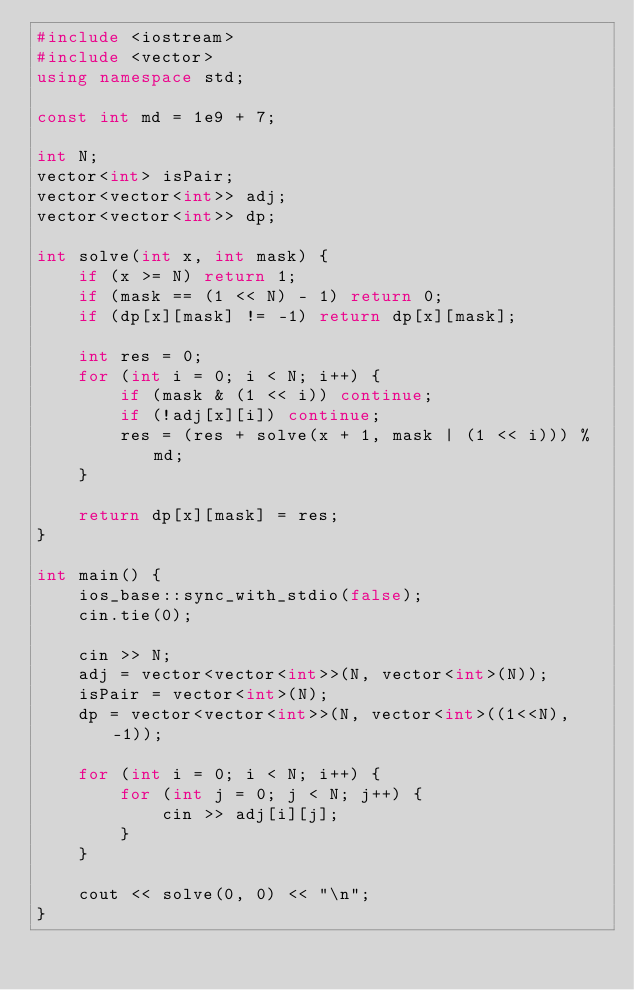<code> <loc_0><loc_0><loc_500><loc_500><_C++_>#include <iostream>
#include <vector>
using namespace std;

const int md = 1e9 + 7;

int N;
vector<int> isPair;
vector<vector<int>> adj;
vector<vector<int>> dp;

int solve(int x, int mask) {
    if (x >= N) return 1;
    if (mask == (1 << N) - 1) return 0;
    if (dp[x][mask] != -1) return dp[x][mask];

    int res = 0;
    for (int i = 0; i < N; i++) {
        if (mask & (1 << i)) continue;
        if (!adj[x][i]) continue;
        res = (res + solve(x + 1, mask | (1 << i))) % md;
    }

    return dp[x][mask] = res;
}

int main() {
    ios_base::sync_with_stdio(false);
    cin.tie(0);

    cin >> N;
    adj = vector<vector<int>>(N, vector<int>(N));
    isPair = vector<int>(N);
    dp = vector<vector<int>>(N, vector<int>((1<<N), -1));

    for (int i = 0; i < N; i++) {
        for (int j = 0; j < N; j++) {
            cin >> adj[i][j];
        }
    }

    cout << solve(0, 0) << "\n";
}

</code> 